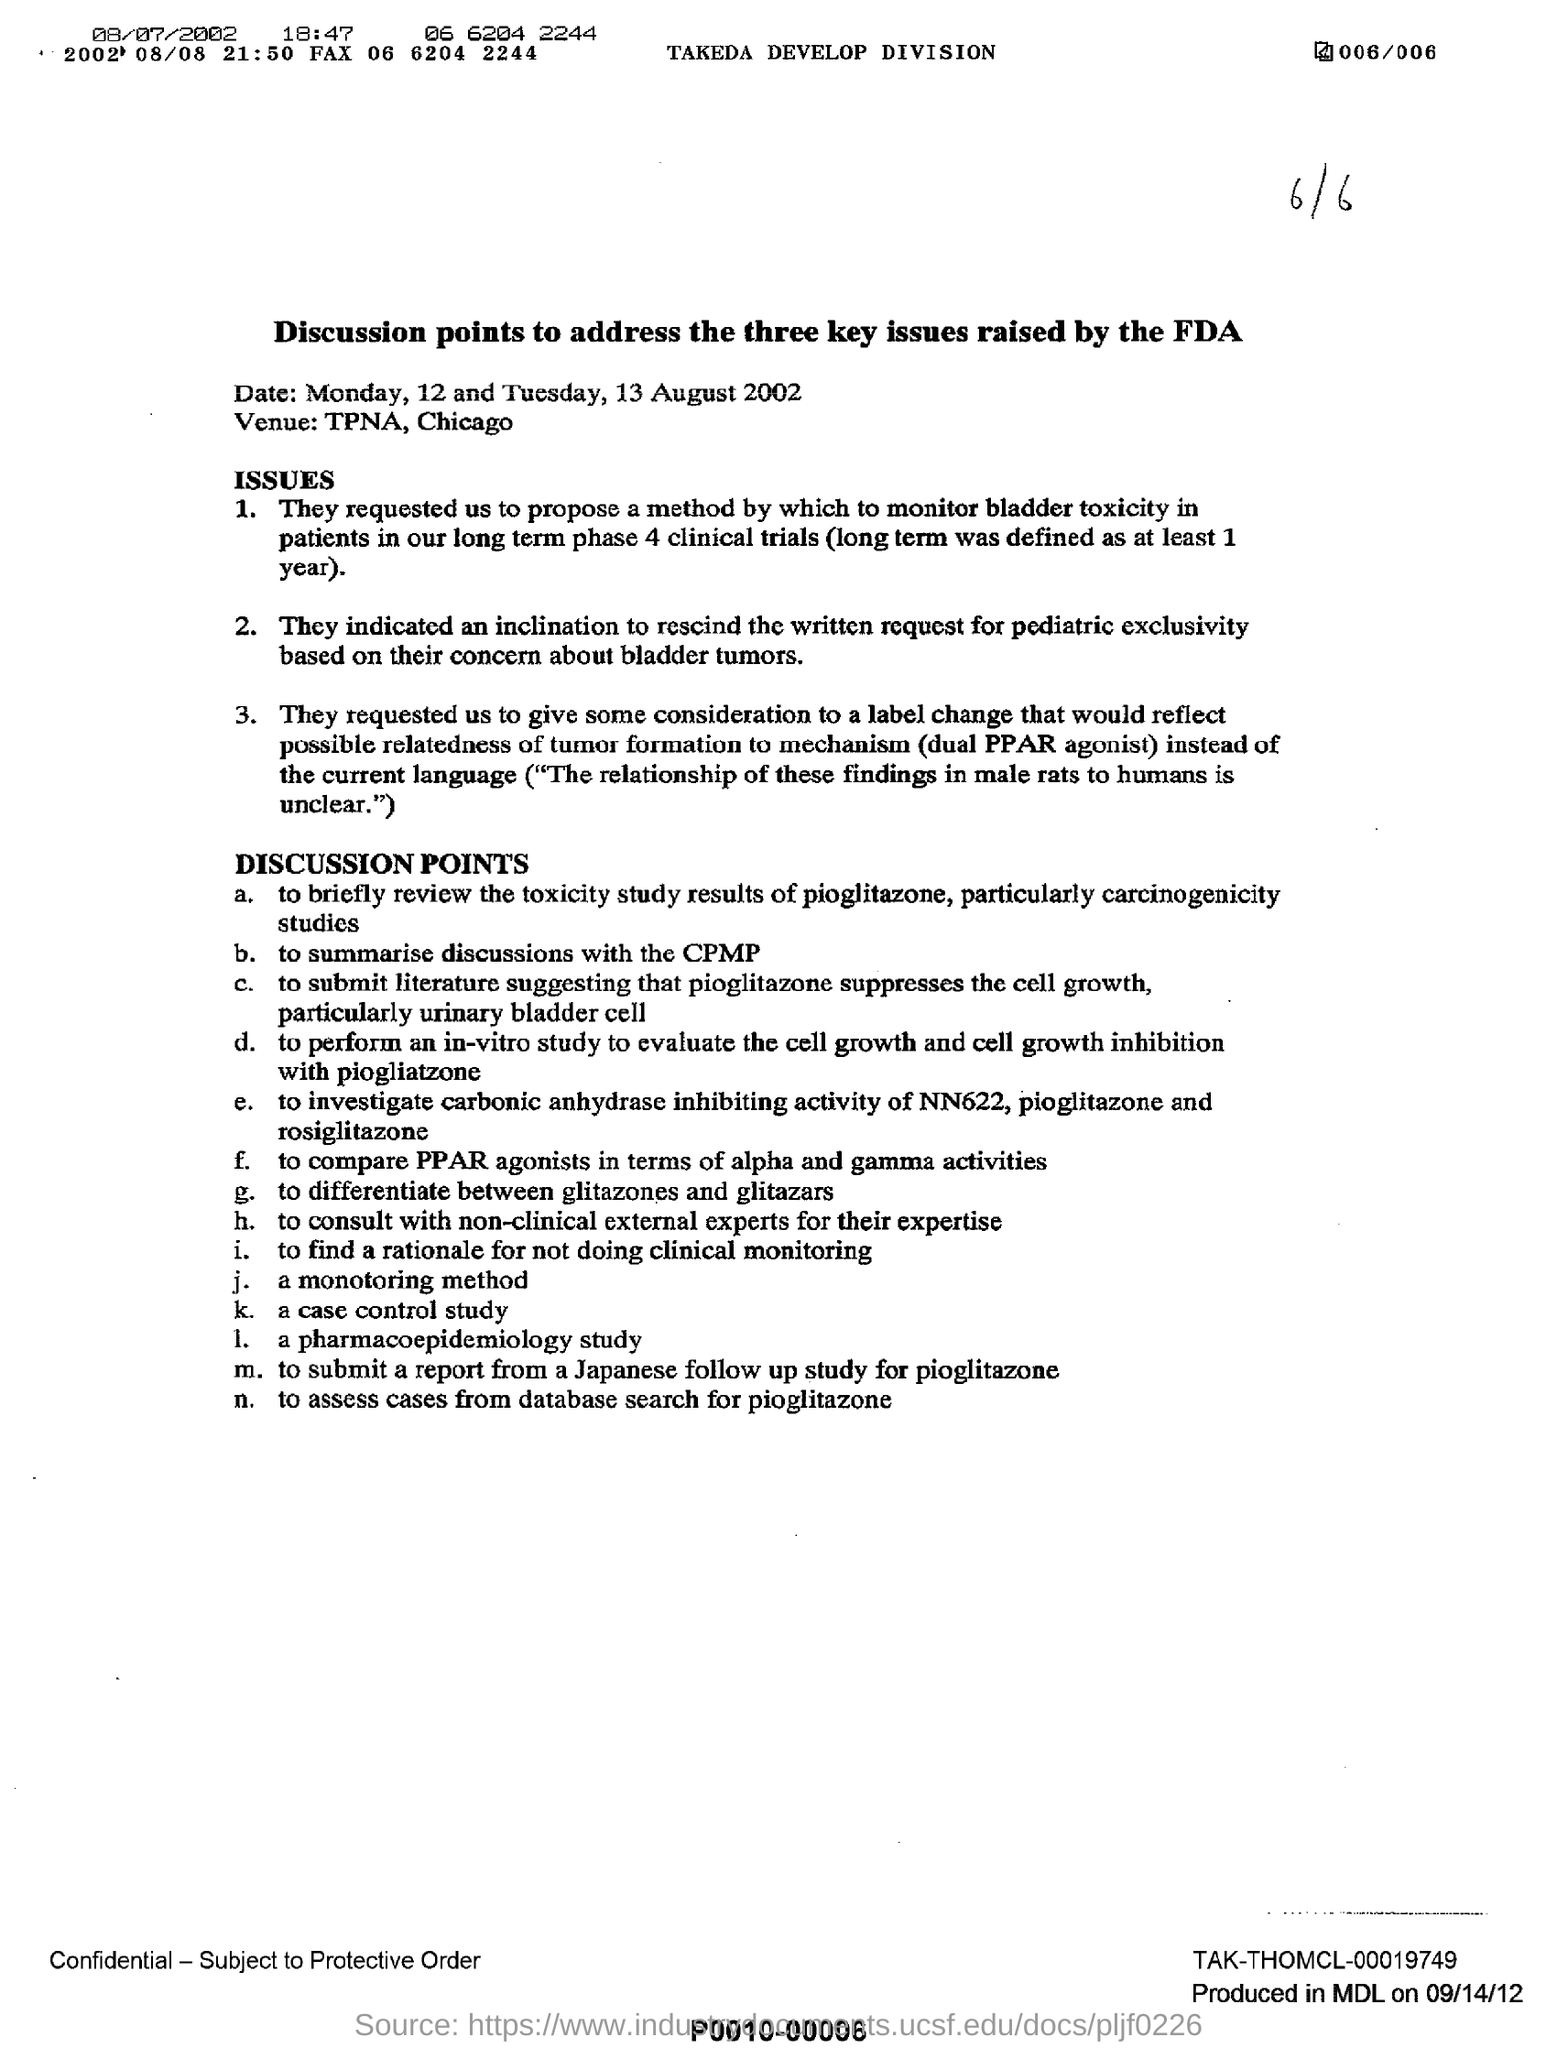Highlight a few significant elements in this photo. The fax number mentioned in the letter at the top is 06 6204 2244. The results of a toxicity study for the drug pioglitazone will be discussed. The date mentioned in the document is August 12 and 13, 2002. The venue mentioned in the document is TPNA, located in Chicago. 